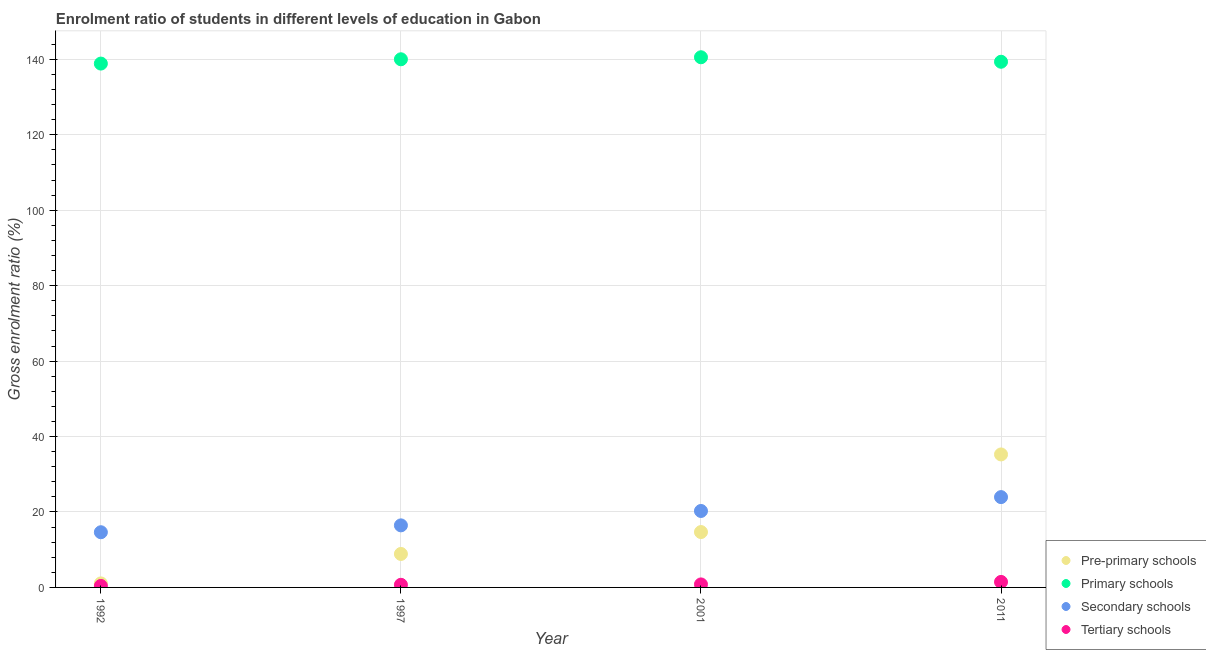How many different coloured dotlines are there?
Offer a very short reply. 4. Is the number of dotlines equal to the number of legend labels?
Offer a terse response. Yes. What is the gross enrolment ratio in secondary schools in 1997?
Make the answer very short. 16.45. Across all years, what is the maximum gross enrolment ratio in tertiary schools?
Your answer should be very brief. 1.46. Across all years, what is the minimum gross enrolment ratio in tertiary schools?
Give a very brief answer. 0.39. What is the total gross enrolment ratio in secondary schools in the graph?
Your answer should be very brief. 75.3. What is the difference between the gross enrolment ratio in pre-primary schools in 1992 and that in 2001?
Give a very brief answer. -13.61. What is the difference between the gross enrolment ratio in tertiary schools in 1997 and the gross enrolment ratio in pre-primary schools in 2011?
Provide a short and direct response. -34.56. What is the average gross enrolment ratio in primary schools per year?
Ensure brevity in your answer.  139.71. In the year 2011, what is the difference between the gross enrolment ratio in pre-primary schools and gross enrolment ratio in primary schools?
Offer a very short reply. -104.11. In how many years, is the gross enrolment ratio in tertiary schools greater than 76 %?
Offer a terse response. 0. What is the ratio of the gross enrolment ratio in primary schools in 1992 to that in 1997?
Offer a very short reply. 0.99. What is the difference between the highest and the second highest gross enrolment ratio in tertiary schools?
Give a very brief answer. 0.66. What is the difference between the highest and the lowest gross enrolment ratio in tertiary schools?
Give a very brief answer. 1.06. Is the sum of the gross enrolment ratio in primary schools in 2001 and 2011 greater than the maximum gross enrolment ratio in secondary schools across all years?
Give a very brief answer. Yes. Is it the case that in every year, the sum of the gross enrolment ratio in secondary schools and gross enrolment ratio in pre-primary schools is greater than the sum of gross enrolment ratio in tertiary schools and gross enrolment ratio in primary schools?
Offer a terse response. No. Does the gross enrolment ratio in pre-primary schools monotonically increase over the years?
Give a very brief answer. Yes. Is the gross enrolment ratio in secondary schools strictly greater than the gross enrolment ratio in tertiary schools over the years?
Offer a terse response. Yes. Is the gross enrolment ratio in tertiary schools strictly less than the gross enrolment ratio in primary schools over the years?
Keep it short and to the point. Yes. Does the graph contain grids?
Your answer should be compact. Yes. Where does the legend appear in the graph?
Keep it short and to the point. Bottom right. How many legend labels are there?
Keep it short and to the point. 4. How are the legend labels stacked?
Your answer should be very brief. Vertical. What is the title of the graph?
Your answer should be very brief. Enrolment ratio of students in different levels of education in Gabon. What is the Gross enrolment ratio (%) of Pre-primary schools in 1992?
Make the answer very short. 1.07. What is the Gross enrolment ratio (%) of Primary schools in 1992?
Provide a short and direct response. 138.89. What is the Gross enrolment ratio (%) in Secondary schools in 1992?
Give a very brief answer. 14.63. What is the Gross enrolment ratio (%) in Tertiary schools in 1992?
Keep it short and to the point. 0.39. What is the Gross enrolment ratio (%) in Pre-primary schools in 1997?
Your answer should be compact. 8.87. What is the Gross enrolment ratio (%) in Primary schools in 1997?
Ensure brevity in your answer.  140.03. What is the Gross enrolment ratio (%) in Secondary schools in 1997?
Your response must be concise. 16.45. What is the Gross enrolment ratio (%) in Tertiary schools in 1997?
Provide a succinct answer. 0.7. What is the Gross enrolment ratio (%) of Pre-primary schools in 2001?
Make the answer very short. 14.68. What is the Gross enrolment ratio (%) of Primary schools in 2001?
Offer a terse response. 140.56. What is the Gross enrolment ratio (%) of Secondary schools in 2001?
Your answer should be compact. 20.27. What is the Gross enrolment ratio (%) of Tertiary schools in 2001?
Your answer should be compact. 0.8. What is the Gross enrolment ratio (%) of Pre-primary schools in 2011?
Keep it short and to the point. 35.26. What is the Gross enrolment ratio (%) of Primary schools in 2011?
Your response must be concise. 139.37. What is the Gross enrolment ratio (%) of Secondary schools in 2011?
Make the answer very short. 23.95. What is the Gross enrolment ratio (%) of Tertiary schools in 2011?
Your answer should be very brief. 1.46. Across all years, what is the maximum Gross enrolment ratio (%) in Pre-primary schools?
Your answer should be compact. 35.26. Across all years, what is the maximum Gross enrolment ratio (%) of Primary schools?
Provide a succinct answer. 140.56. Across all years, what is the maximum Gross enrolment ratio (%) of Secondary schools?
Your response must be concise. 23.95. Across all years, what is the maximum Gross enrolment ratio (%) of Tertiary schools?
Ensure brevity in your answer.  1.46. Across all years, what is the minimum Gross enrolment ratio (%) of Pre-primary schools?
Your answer should be compact. 1.07. Across all years, what is the minimum Gross enrolment ratio (%) of Primary schools?
Your response must be concise. 138.89. Across all years, what is the minimum Gross enrolment ratio (%) of Secondary schools?
Your answer should be compact. 14.63. Across all years, what is the minimum Gross enrolment ratio (%) of Tertiary schools?
Your answer should be very brief. 0.39. What is the total Gross enrolment ratio (%) of Pre-primary schools in the graph?
Offer a terse response. 59.88. What is the total Gross enrolment ratio (%) of Primary schools in the graph?
Provide a short and direct response. 558.85. What is the total Gross enrolment ratio (%) of Secondary schools in the graph?
Your answer should be very brief. 75.3. What is the total Gross enrolment ratio (%) of Tertiary schools in the graph?
Your answer should be very brief. 3.35. What is the difference between the Gross enrolment ratio (%) of Pre-primary schools in 1992 and that in 1997?
Offer a very short reply. -7.81. What is the difference between the Gross enrolment ratio (%) in Primary schools in 1992 and that in 1997?
Keep it short and to the point. -1.14. What is the difference between the Gross enrolment ratio (%) in Secondary schools in 1992 and that in 1997?
Provide a short and direct response. -1.82. What is the difference between the Gross enrolment ratio (%) in Tertiary schools in 1992 and that in 1997?
Your response must be concise. -0.3. What is the difference between the Gross enrolment ratio (%) of Pre-primary schools in 1992 and that in 2001?
Provide a succinct answer. -13.61. What is the difference between the Gross enrolment ratio (%) in Primary schools in 1992 and that in 2001?
Offer a very short reply. -1.68. What is the difference between the Gross enrolment ratio (%) of Secondary schools in 1992 and that in 2001?
Offer a terse response. -5.64. What is the difference between the Gross enrolment ratio (%) of Tertiary schools in 1992 and that in 2001?
Offer a very short reply. -0.41. What is the difference between the Gross enrolment ratio (%) in Pre-primary schools in 1992 and that in 2011?
Provide a succinct answer. -34.19. What is the difference between the Gross enrolment ratio (%) of Primary schools in 1992 and that in 2011?
Your answer should be compact. -0.48. What is the difference between the Gross enrolment ratio (%) in Secondary schools in 1992 and that in 2011?
Offer a terse response. -9.31. What is the difference between the Gross enrolment ratio (%) of Tertiary schools in 1992 and that in 2011?
Provide a short and direct response. -1.06. What is the difference between the Gross enrolment ratio (%) of Pre-primary schools in 1997 and that in 2001?
Your answer should be compact. -5.81. What is the difference between the Gross enrolment ratio (%) of Primary schools in 1997 and that in 2001?
Your response must be concise. -0.54. What is the difference between the Gross enrolment ratio (%) of Secondary schools in 1997 and that in 2001?
Offer a terse response. -3.82. What is the difference between the Gross enrolment ratio (%) of Tertiary schools in 1997 and that in 2001?
Your answer should be compact. -0.1. What is the difference between the Gross enrolment ratio (%) of Pre-primary schools in 1997 and that in 2011?
Keep it short and to the point. -26.39. What is the difference between the Gross enrolment ratio (%) of Primary schools in 1997 and that in 2011?
Your answer should be very brief. 0.66. What is the difference between the Gross enrolment ratio (%) in Secondary schools in 1997 and that in 2011?
Provide a succinct answer. -7.49. What is the difference between the Gross enrolment ratio (%) of Tertiary schools in 1997 and that in 2011?
Your response must be concise. -0.76. What is the difference between the Gross enrolment ratio (%) in Pre-primary schools in 2001 and that in 2011?
Give a very brief answer. -20.58. What is the difference between the Gross enrolment ratio (%) in Primary schools in 2001 and that in 2011?
Provide a succinct answer. 1.19. What is the difference between the Gross enrolment ratio (%) of Secondary schools in 2001 and that in 2011?
Your response must be concise. -3.68. What is the difference between the Gross enrolment ratio (%) in Tertiary schools in 2001 and that in 2011?
Your response must be concise. -0.66. What is the difference between the Gross enrolment ratio (%) of Pre-primary schools in 1992 and the Gross enrolment ratio (%) of Primary schools in 1997?
Make the answer very short. -138.96. What is the difference between the Gross enrolment ratio (%) of Pre-primary schools in 1992 and the Gross enrolment ratio (%) of Secondary schools in 1997?
Make the answer very short. -15.39. What is the difference between the Gross enrolment ratio (%) in Pre-primary schools in 1992 and the Gross enrolment ratio (%) in Tertiary schools in 1997?
Offer a terse response. 0.37. What is the difference between the Gross enrolment ratio (%) of Primary schools in 1992 and the Gross enrolment ratio (%) of Secondary schools in 1997?
Provide a short and direct response. 122.43. What is the difference between the Gross enrolment ratio (%) of Primary schools in 1992 and the Gross enrolment ratio (%) of Tertiary schools in 1997?
Your response must be concise. 138.19. What is the difference between the Gross enrolment ratio (%) of Secondary schools in 1992 and the Gross enrolment ratio (%) of Tertiary schools in 1997?
Keep it short and to the point. 13.94. What is the difference between the Gross enrolment ratio (%) of Pre-primary schools in 1992 and the Gross enrolment ratio (%) of Primary schools in 2001?
Provide a succinct answer. -139.5. What is the difference between the Gross enrolment ratio (%) in Pre-primary schools in 1992 and the Gross enrolment ratio (%) in Secondary schools in 2001?
Provide a succinct answer. -19.2. What is the difference between the Gross enrolment ratio (%) of Pre-primary schools in 1992 and the Gross enrolment ratio (%) of Tertiary schools in 2001?
Give a very brief answer. 0.27. What is the difference between the Gross enrolment ratio (%) of Primary schools in 1992 and the Gross enrolment ratio (%) of Secondary schools in 2001?
Provide a succinct answer. 118.62. What is the difference between the Gross enrolment ratio (%) in Primary schools in 1992 and the Gross enrolment ratio (%) in Tertiary schools in 2001?
Your answer should be very brief. 138.09. What is the difference between the Gross enrolment ratio (%) of Secondary schools in 1992 and the Gross enrolment ratio (%) of Tertiary schools in 2001?
Your response must be concise. 13.84. What is the difference between the Gross enrolment ratio (%) in Pre-primary schools in 1992 and the Gross enrolment ratio (%) in Primary schools in 2011?
Keep it short and to the point. -138.3. What is the difference between the Gross enrolment ratio (%) of Pre-primary schools in 1992 and the Gross enrolment ratio (%) of Secondary schools in 2011?
Your answer should be very brief. -22.88. What is the difference between the Gross enrolment ratio (%) of Pre-primary schools in 1992 and the Gross enrolment ratio (%) of Tertiary schools in 2011?
Make the answer very short. -0.39. What is the difference between the Gross enrolment ratio (%) of Primary schools in 1992 and the Gross enrolment ratio (%) of Secondary schools in 2011?
Provide a succinct answer. 114.94. What is the difference between the Gross enrolment ratio (%) of Primary schools in 1992 and the Gross enrolment ratio (%) of Tertiary schools in 2011?
Your response must be concise. 137.43. What is the difference between the Gross enrolment ratio (%) in Secondary schools in 1992 and the Gross enrolment ratio (%) in Tertiary schools in 2011?
Your answer should be very brief. 13.18. What is the difference between the Gross enrolment ratio (%) in Pre-primary schools in 1997 and the Gross enrolment ratio (%) in Primary schools in 2001?
Provide a short and direct response. -131.69. What is the difference between the Gross enrolment ratio (%) in Pre-primary schools in 1997 and the Gross enrolment ratio (%) in Secondary schools in 2001?
Keep it short and to the point. -11.4. What is the difference between the Gross enrolment ratio (%) of Pre-primary schools in 1997 and the Gross enrolment ratio (%) of Tertiary schools in 2001?
Your response must be concise. 8.07. What is the difference between the Gross enrolment ratio (%) in Primary schools in 1997 and the Gross enrolment ratio (%) in Secondary schools in 2001?
Offer a very short reply. 119.76. What is the difference between the Gross enrolment ratio (%) in Primary schools in 1997 and the Gross enrolment ratio (%) in Tertiary schools in 2001?
Offer a terse response. 139.23. What is the difference between the Gross enrolment ratio (%) in Secondary schools in 1997 and the Gross enrolment ratio (%) in Tertiary schools in 2001?
Provide a succinct answer. 15.65. What is the difference between the Gross enrolment ratio (%) in Pre-primary schools in 1997 and the Gross enrolment ratio (%) in Primary schools in 2011?
Offer a terse response. -130.5. What is the difference between the Gross enrolment ratio (%) in Pre-primary schools in 1997 and the Gross enrolment ratio (%) in Secondary schools in 2011?
Offer a very short reply. -15.07. What is the difference between the Gross enrolment ratio (%) of Pre-primary schools in 1997 and the Gross enrolment ratio (%) of Tertiary schools in 2011?
Give a very brief answer. 7.42. What is the difference between the Gross enrolment ratio (%) of Primary schools in 1997 and the Gross enrolment ratio (%) of Secondary schools in 2011?
Offer a terse response. 116.08. What is the difference between the Gross enrolment ratio (%) in Primary schools in 1997 and the Gross enrolment ratio (%) in Tertiary schools in 2011?
Your response must be concise. 138.57. What is the difference between the Gross enrolment ratio (%) of Secondary schools in 1997 and the Gross enrolment ratio (%) of Tertiary schools in 2011?
Offer a terse response. 15. What is the difference between the Gross enrolment ratio (%) of Pre-primary schools in 2001 and the Gross enrolment ratio (%) of Primary schools in 2011?
Offer a very short reply. -124.69. What is the difference between the Gross enrolment ratio (%) in Pre-primary schools in 2001 and the Gross enrolment ratio (%) in Secondary schools in 2011?
Your answer should be compact. -9.27. What is the difference between the Gross enrolment ratio (%) in Pre-primary schools in 2001 and the Gross enrolment ratio (%) in Tertiary schools in 2011?
Your answer should be compact. 13.22. What is the difference between the Gross enrolment ratio (%) in Primary schools in 2001 and the Gross enrolment ratio (%) in Secondary schools in 2011?
Offer a terse response. 116.62. What is the difference between the Gross enrolment ratio (%) in Primary schools in 2001 and the Gross enrolment ratio (%) in Tertiary schools in 2011?
Your response must be concise. 139.11. What is the difference between the Gross enrolment ratio (%) of Secondary schools in 2001 and the Gross enrolment ratio (%) of Tertiary schools in 2011?
Give a very brief answer. 18.81. What is the average Gross enrolment ratio (%) of Pre-primary schools per year?
Your answer should be compact. 14.97. What is the average Gross enrolment ratio (%) of Primary schools per year?
Ensure brevity in your answer.  139.71. What is the average Gross enrolment ratio (%) of Secondary schools per year?
Give a very brief answer. 18.83. What is the average Gross enrolment ratio (%) of Tertiary schools per year?
Offer a terse response. 0.84. In the year 1992, what is the difference between the Gross enrolment ratio (%) in Pre-primary schools and Gross enrolment ratio (%) in Primary schools?
Offer a terse response. -137.82. In the year 1992, what is the difference between the Gross enrolment ratio (%) of Pre-primary schools and Gross enrolment ratio (%) of Secondary schools?
Make the answer very short. -13.57. In the year 1992, what is the difference between the Gross enrolment ratio (%) in Pre-primary schools and Gross enrolment ratio (%) in Tertiary schools?
Your answer should be compact. 0.67. In the year 1992, what is the difference between the Gross enrolment ratio (%) of Primary schools and Gross enrolment ratio (%) of Secondary schools?
Your response must be concise. 124.25. In the year 1992, what is the difference between the Gross enrolment ratio (%) in Primary schools and Gross enrolment ratio (%) in Tertiary schools?
Your response must be concise. 138.49. In the year 1992, what is the difference between the Gross enrolment ratio (%) in Secondary schools and Gross enrolment ratio (%) in Tertiary schools?
Offer a terse response. 14.24. In the year 1997, what is the difference between the Gross enrolment ratio (%) in Pre-primary schools and Gross enrolment ratio (%) in Primary schools?
Offer a very short reply. -131.15. In the year 1997, what is the difference between the Gross enrolment ratio (%) of Pre-primary schools and Gross enrolment ratio (%) of Secondary schools?
Offer a terse response. -7.58. In the year 1997, what is the difference between the Gross enrolment ratio (%) in Pre-primary schools and Gross enrolment ratio (%) in Tertiary schools?
Your answer should be very brief. 8.18. In the year 1997, what is the difference between the Gross enrolment ratio (%) in Primary schools and Gross enrolment ratio (%) in Secondary schools?
Ensure brevity in your answer.  123.58. In the year 1997, what is the difference between the Gross enrolment ratio (%) of Primary schools and Gross enrolment ratio (%) of Tertiary schools?
Ensure brevity in your answer.  139.33. In the year 1997, what is the difference between the Gross enrolment ratio (%) of Secondary schools and Gross enrolment ratio (%) of Tertiary schools?
Your answer should be very brief. 15.76. In the year 2001, what is the difference between the Gross enrolment ratio (%) of Pre-primary schools and Gross enrolment ratio (%) of Primary schools?
Your answer should be compact. -125.88. In the year 2001, what is the difference between the Gross enrolment ratio (%) in Pre-primary schools and Gross enrolment ratio (%) in Secondary schools?
Provide a succinct answer. -5.59. In the year 2001, what is the difference between the Gross enrolment ratio (%) in Pre-primary schools and Gross enrolment ratio (%) in Tertiary schools?
Ensure brevity in your answer.  13.88. In the year 2001, what is the difference between the Gross enrolment ratio (%) in Primary schools and Gross enrolment ratio (%) in Secondary schools?
Make the answer very short. 120.29. In the year 2001, what is the difference between the Gross enrolment ratio (%) of Primary schools and Gross enrolment ratio (%) of Tertiary schools?
Your response must be concise. 139.76. In the year 2001, what is the difference between the Gross enrolment ratio (%) of Secondary schools and Gross enrolment ratio (%) of Tertiary schools?
Make the answer very short. 19.47. In the year 2011, what is the difference between the Gross enrolment ratio (%) of Pre-primary schools and Gross enrolment ratio (%) of Primary schools?
Offer a terse response. -104.11. In the year 2011, what is the difference between the Gross enrolment ratio (%) of Pre-primary schools and Gross enrolment ratio (%) of Secondary schools?
Provide a succinct answer. 11.31. In the year 2011, what is the difference between the Gross enrolment ratio (%) in Pre-primary schools and Gross enrolment ratio (%) in Tertiary schools?
Ensure brevity in your answer.  33.8. In the year 2011, what is the difference between the Gross enrolment ratio (%) in Primary schools and Gross enrolment ratio (%) in Secondary schools?
Offer a terse response. 115.43. In the year 2011, what is the difference between the Gross enrolment ratio (%) of Primary schools and Gross enrolment ratio (%) of Tertiary schools?
Keep it short and to the point. 137.91. In the year 2011, what is the difference between the Gross enrolment ratio (%) in Secondary schools and Gross enrolment ratio (%) in Tertiary schools?
Offer a terse response. 22.49. What is the ratio of the Gross enrolment ratio (%) in Pre-primary schools in 1992 to that in 1997?
Ensure brevity in your answer.  0.12. What is the ratio of the Gross enrolment ratio (%) of Primary schools in 1992 to that in 1997?
Give a very brief answer. 0.99. What is the ratio of the Gross enrolment ratio (%) in Secondary schools in 1992 to that in 1997?
Make the answer very short. 0.89. What is the ratio of the Gross enrolment ratio (%) in Tertiary schools in 1992 to that in 1997?
Ensure brevity in your answer.  0.57. What is the ratio of the Gross enrolment ratio (%) in Pre-primary schools in 1992 to that in 2001?
Ensure brevity in your answer.  0.07. What is the ratio of the Gross enrolment ratio (%) in Primary schools in 1992 to that in 2001?
Provide a short and direct response. 0.99. What is the ratio of the Gross enrolment ratio (%) of Secondary schools in 1992 to that in 2001?
Your answer should be compact. 0.72. What is the ratio of the Gross enrolment ratio (%) of Tertiary schools in 1992 to that in 2001?
Offer a terse response. 0.49. What is the ratio of the Gross enrolment ratio (%) of Pre-primary schools in 1992 to that in 2011?
Give a very brief answer. 0.03. What is the ratio of the Gross enrolment ratio (%) in Secondary schools in 1992 to that in 2011?
Make the answer very short. 0.61. What is the ratio of the Gross enrolment ratio (%) in Tertiary schools in 1992 to that in 2011?
Your answer should be compact. 0.27. What is the ratio of the Gross enrolment ratio (%) in Pre-primary schools in 1997 to that in 2001?
Your answer should be very brief. 0.6. What is the ratio of the Gross enrolment ratio (%) in Primary schools in 1997 to that in 2001?
Make the answer very short. 1. What is the ratio of the Gross enrolment ratio (%) of Secondary schools in 1997 to that in 2001?
Offer a terse response. 0.81. What is the ratio of the Gross enrolment ratio (%) in Tertiary schools in 1997 to that in 2001?
Make the answer very short. 0.87. What is the ratio of the Gross enrolment ratio (%) of Pre-primary schools in 1997 to that in 2011?
Keep it short and to the point. 0.25. What is the ratio of the Gross enrolment ratio (%) in Primary schools in 1997 to that in 2011?
Your answer should be compact. 1. What is the ratio of the Gross enrolment ratio (%) in Secondary schools in 1997 to that in 2011?
Ensure brevity in your answer.  0.69. What is the ratio of the Gross enrolment ratio (%) of Tertiary schools in 1997 to that in 2011?
Give a very brief answer. 0.48. What is the ratio of the Gross enrolment ratio (%) in Pre-primary schools in 2001 to that in 2011?
Provide a short and direct response. 0.42. What is the ratio of the Gross enrolment ratio (%) in Primary schools in 2001 to that in 2011?
Provide a succinct answer. 1.01. What is the ratio of the Gross enrolment ratio (%) of Secondary schools in 2001 to that in 2011?
Give a very brief answer. 0.85. What is the ratio of the Gross enrolment ratio (%) of Tertiary schools in 2001 to that in 2011?
Your answer should be compact. 0.55. What is the difference between the highest and the second highest Gross enrolment ratio (%) of Pre-primary schools?
Your answer should be very brief. 20.58. What is the difference between the highest and the second highest Gross enrolment ratio (%) in Primary schools?
Keep it short and to the point. 0.54. What is the difference between the highest and the second highest Gross enrolment ratio (%) of Secondary schools?
Provide a short and direct response. 3.68. What is the difference between the highest and the second highest Gross enrolment ratio (%) of Tertiary schools?
Your response must be concise. 0.66. What is the difference between the highest and the lowest Gross enrolment ratio (%) of Pre-primary schools?
Provide a succinct answer. 34.19. What is the difference between the highest and the lowest Gross enrolment ratio (%) of Primary schools?
Provide a short and direct response. 1.68. What is the difference between the highest and the lowest Gross enrolment ratio (%) of Secondary schools?
Give a very brief answer. 9.31. What is the difference between the highest and the lowest Gross enrolment ratio (%) in Tertiary schools?
Provide a short and direct response. 1.06. 